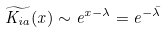Convert formula to latex. <formula><loc_0><loc_0><loc_500><loc_500>\widetilde { K _ { i a } } ( x ) \sim e ^ { x - \lambda } = e ^ { - \bar { \lambda } }</formula> 